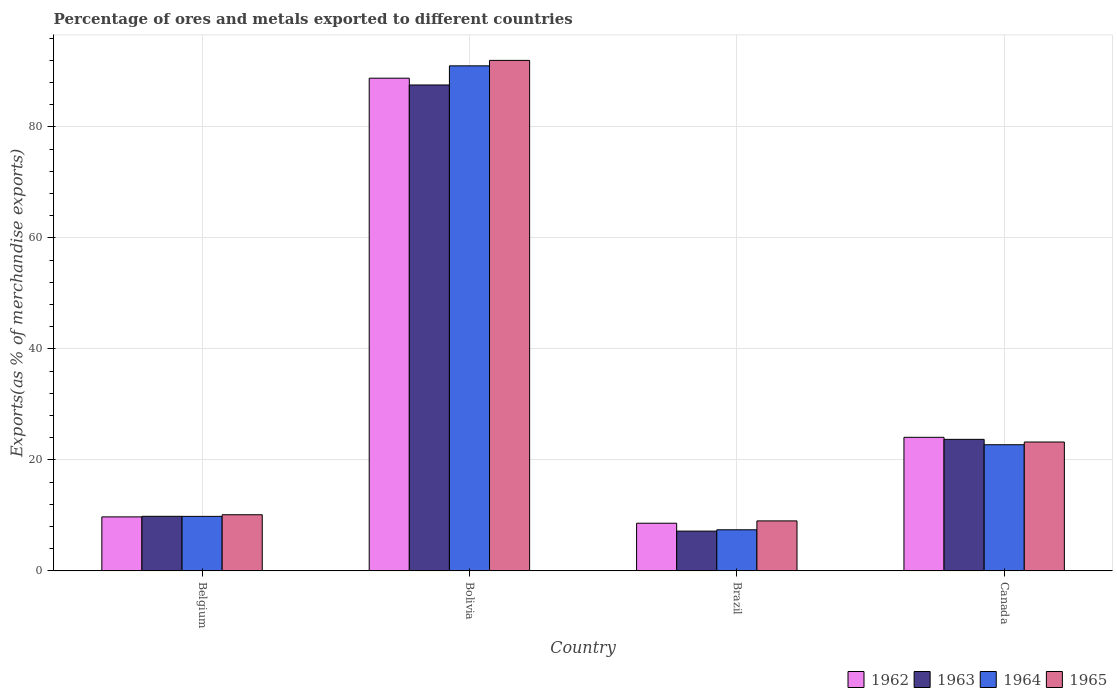How many different coloured bars are there?
Your answer should be very brief. 4. Are the number of bars on each tick of the X-axis equal?
Offer a very short reply. Yes. What is the label of the 1st group of bars from the left?
Provide a succinct answer. Belgium. In how many cases, is the number of bars for a given country not equal to the number of legend labels?
Make the answer very short. 0. What is the percentage of exports to different countries in 1964 in Brazil?
Offer a very short reply. 7.41. Across all countries, what is the maximum percentage of exports to different countries in 1965?
Offer a terse response. 92. Across all countries, what is the minimum percentage of exports to different countries in 1964?
Your answer should be compact. 7.41. What is the total percentage of exports to different countries in 1964 in the graph?
Offer a very short reply. 130.99. What is the difference between the percentage of exports to different countries in 1965 in Bolivia and that in Brazil?
Make the answer very short. 82.99. What is the difference between the percentage of exports to different countries in 1965 in Belgium and the percentage of exports to different countries in 1963 in Canada?
Provide a short and direct response. -13.59. What is the average percentage of exports to different countries in 1964 per country?
Give a very brief answer. 32.75. What is the difference between the percentage of exports to different countries of/in 1964 and percentage of exports to different countries of/in 1965 in Bolivia?
Your answer should be compact. -0.98. What is the ratio of the percentage of exports to different countries in 1963 in Bolivia to that in Canada?
Provide a succinct answer. 3.69. Is the percentage of exports to different countries in 1964 in Belgium less than that in Bolivia?
Your answer should be compact. Yes. What is the difference between the highest and the second highest percentage of exports to different countries in 1965?
Provide a succinct answer. -81.88. What is the difference between the highest and the lowest percentage of exports to different countries in 1965?
Give a very brief answer. 82.99. In how many countries, is the percentage of exports to different countries in 1964 greater than the average percentage of exports to different countries in 1964 taken over all countries?
Ensure brevity in your answer.  1. Is it the case that in every country, the sum of the percentage of exports to different countries in 1963 and percentage of exports to different countries in 1964 is greater than the sum of percentage of exports to different countries in 1962 and percentage of exports to different countries in 1965?
Your response must be concise. No. What does the 4th bar from the left in Belgium represents?
Offer a terse response. 1965. What does the 2nd bar from the right in Bolivia represents?
Give a very brief answer. 1964. Is it the case that in every country, the sum of the percentage of exports to different countries in 1965 and percentage of exports to different countries in 1963 is greater than the percentage of exports to different countries in 1962?
Ensure brevity in your answer.  Yes. How many countries are there in the graph?
Your answer should be very brief. 4. What is the difference between two consecutive major ticks on the Y-axis?
Provide a short and direct response. 20. Are the values on the major ticks of Y-axis written in scientific E-notation?
Offer a very short reply. No. Does the graph contain any zero values?
Give a very brief answer. No. How many legend labels are there?
Make the answer very short. 4. How are the legend labels stacked?
Your answer should be very brief. Horizontal. What is the title of the graph?
Keep it short and to the point. Percentage of ores and metals exported to different countries. What is the label or title of the X-axis?
Provide a succinct answer. Country. What is the label or title of the Y-axis?
Offer a terse response. Exports(as % of merchandise exports). What is the Exports(as % of merchandise exports) of 1962 in Belgium?
Keep it short and to the point. 9.73. What is the Exports(as % of merchandise exports) in 1963 in Belgium?
Keep it short and to the point. 9.84. What is the Exports(as % of merchandise exports) in 1964 in Belgium?
Provide a succinct answer. 9.83. What is the Exports(as % of merchandise exports) in 1965 in Belgium?
Your answer should be compact. 10.12. What is the Exports(as % of merchandise exports) in 1962 in Bolivia?
Your answer should be compact. 88.79. What is the Exports(as % of merchandise exports) in 1963 in Bolivia?
Your response must be concise. 87.57. What is the Exports(as % of merchandise exports) in 1964 in Bolivia?
Provide a succinct answer. 91.02. What is the Exports(as % of merchandise exports) in 1965 in Bolivia?
Offer a very short reply. 92. What is the Exports(as % of merchandise exports) of 1962 in Brazil?
Keep it short and to the point. 8.59. What is the Exports(as % of merchandise exports) in 1963 in Brazil?
Ensure brevity in your answer.  7.17. What is the Exports(as % of merchandise exports) in 1964 in Brazil?
Offer a terse response. 7.41. What is the Exports(as % of merchandise exports) in 1965 in Brazil?
Offer a terse response. 9.01. What is the Exports(as % of merchandise exports) in 1962 in Canada?
Offer a very short reply. 24.07. What is the Exports(as % of merchandise exports) in 1963 in Canada?
Your answer should be very brief. 23.71. What is the Exports(as % of merchandise exports) of 1964 in Canada?
Offer a very short reply. 22.74. What is the Exports(as % of merchandise exports) of 1965 in Canada?
Your answer should be compact. 23.23. Across all countries, what is the maximum Exports(as % of merchandise exports) of 1962?
Provide a short and direct response. 88.79. Across all countries, what is the maximum Exports(as % of merchandise exports) of 1963?
Keep it short and to the point. 87.57. Across all countries, what is the maximum Exports(as % of merchandise exports) in 1964?
Keep it short and to the point. 91.02. Across all countries, what is the maximum Exports(as % of merchandise exports) in 1965?
Your answer should be compact. 92. Across all countries, what is the minimum Exports(as % of merchandise exports) in 1962?
Your answer should be compact. 8.59. Across all countries, what is the minimum Exports(as % of merchandise exports) in 1963?
Your answer should be compact. 7.17. Across all countries, what is the minimum Exports(as % of merchandise exports) in 1964?
Provide a succinct answer. 7.41. Across all countries, what is the minimum Exports(as % of merchandise exports) of 1965?
Provide a succinct answer. 9.01. What is the total Exports(as % of merchandise exports) in 1962 in the graph?
Your answer should be compact. 131.19. What is the total Exports(as % of merchandise exports) in 1963 in the graph?
Give a very brief answer. 128.28. What is the total Exports(as % of merchandise exports) of 1964 in the graph?
Your answer should be compact. 130.99. What is the total Exports(as % of merchandise exports) in 1965 in the graph?
Your response must be concise. 134.36. What is the difference between the Exports(as % of merchandise exports) of 1962 in Belgium and that in Bolivia?
Ensure brevity in your answer.  -79.06. What is the difference between the Exports(as % of merchandise exports) in 1963 in Belgium and that in Bolivia?
Offer a terse response. -77.73. What is the difference between the Exports(as % of merchandise exports) of 1964 in Belgium and that in Bolivia?
Your answer should be compact. -81.19. What is the difference between the Exports(as % of merchandise exports) of 1965 in Belgium and that in Bolivia?
Offer a very short reply. -81.88. What is the difference between the Exports(as % of merchandise exports) in 1962 in Belgium and that in Brazil?
Offer a terse response. 1.14. What is the difference between the Exports(as % of merchandise exports) in 1963 in Belgium and that in Brazil?
Make the answer very short. 2.67. What is the difference between the Exports(as % of merchandise exports) of 1964 in Belgium and that in Brazil?
Offer a terse response. 2.42. What is the difference between the Exports(as % of merchandise exports) in 1965 in Belgium and that in Brazil?
Offer a terse response. 1.11. What is the difference between the Exports(as % of merchandise exports) in 1962 in Belgium and that in Canada?
Make the answer very short. -14.34. What is the difference between the Exports(as % of merchandise exports) in 1963 in Belgium and that in Canada?
Make the answer very short. -13.87. What is the difference between the Exports(as % of merchandise exports) of 1964 in Belgium and that in Canada?
Offer a terse response. -12.91. What is the difference between the Exports(as % of merchandise exports) of 1965 in Belgium and that in Canada?
Offer a very short reply. -13.11. What is the difference between the Exports(as % of merchandise exports) of 1962 in Bolivia and that in Brazil?
Provide a succinct answer. 80.2. What is the difference between the Exports(as % of merchandise exports) in 1963 in Bolivia and that in Brazil?
Keep it short and to the point. 80.4. What is the difference between the Exports(as % of merchandise exports) of 1964 in Bolivia and that in Brazil?
Provide a short and direct response. 83.61. What is the difference between the Exports(as % of merchandise exports) of 1965 in Bolivia and that in Brazil?
Provide a succinct answer. 82.99. What is the difference between the Exports(as % of merchandise exports) in 1962 in Bolivia and that in Canada?
Your answer should be very brief. 64.72. What is the difference between the Exports(as % of merchandise exports) in 1963 in Bolivia and that in Canada?
Your response must be concise. 63.86. What is the difference between the Exports(as % of merchandise exports) of 1964 in Bolivia and that in Canada?
Offer a terse response. 68.28. What is the difference between the Exports(as % of merchandise exports) in 1965 in Bolivia and that in Canada?
Your answer should be very brief. 68.77. What is the difference between the Exports(as % of merchandise exports) of 1962 in Brazil and that in Canada?
Offer a terse response. -15.48. What is the difference between the Exports(as % of merchandise exports) of 1963 in Brazil and that in Canada?
Provide a short and direct response. -16.54. What is the difference between the Exports(as % of merchandise exports) in 1964 in Brazil and that in Canada?
Offer a terse response. -15.33. What is the difference between the Exports(as % of merchandise exports) in 1965 in Brazil and that in Canada?
Offer a very short reply. -14.22. What is the difference between the Exports(as % of merchandise exports) of 1962 in Belgium and the Exports(as % of merchandise exports) of 1963 in Bolivia?
Provide a succinct answer. -77.84. What is the difference between the Exports(as % of merchandise exports) in 1962 in Belgium and the Exports(as % of merchandise exports) in 1964 in Bolivia?
Offer a terse response. -81.28. What is the difference between the Exports(as % of merchandise exports) of 1962 in Belgium and the Exports(as % of merchandise exports) of 1965 in Bolivia?
Offer a very short reply. -82.27. What is the difference between the Exports(as % of merchandise exports) of 1963 in Belgium and the Exports(as % of merchandise exports) of 1964 in Bolivia?
Give a very brief answer. -81.18. What is the difference between the Exports(as % of merchandise exports) of 1963 in Belgium and the Exports(as % of merchandise exports) of 1965 in Bolivia?
Provide a succinct answer. -82.16. What is the difference between the Exports(as % of merchandise exports) of 1964 in Belgium and the Exports(as % of merchandise exports) of 1965 in Bolivia?
Your response must be concise. -82.17. What is the difference between the Exports(as % of merchandise exports) of 1962 in Belgium and the Exports(as % of merchandise exports) of 1963 in Brazil?
Give a very brief answer. 2.56. What is the difference between the Exports(as % of merchandise exports) of 1962 in Belgium and the Exports(as % of merchandise exports) of 1964 in Brazil?
Your answer should be compact. 2.33. What is the difference between the Exports(as % of merchandise exports) in 1962 in Belgium and the Exports(as % of merchandise exports) in 1965 in Brazil?
Make the answer very short. 0.72. What is the difference between the Exports(as % of merchandise exports) of 1963 in Belgium and the Exports(as % of merchandise exports) of 1964 in Brazil?
Your answer should be compact. 2.43. What is the difference between the Exports(as % of merchandise exports) in 1963 in Belgium and the Exports(as % of merchandise exports) in 1965 in Brazil?
Offer a very short reply. 0.83. What is the difference between the Exports(as % of merchandise exports) in 1964 in Belgium and the Exports(as % of merchandise exports) in 1965 in Brazil?
Your answer should be very brief. 0.82. What is the difference between the Exports(as % of merchandise exports) in 1962 in Belgium and the Exports(as % of merchandise exports) in 1963 in Canada?
Provide a short and direct response. -13.97. What is the difference between the Exports(as % of merchandise exports) in 1962 in Belgium and the Exports(as % of merchandise exports) in 1964 in Canada?
Your response must be concise. -13. What is the difference between the Exports(as % of merchandise exports) of 1962 in Belgium and the Exports(as % of merchandise exports) of 1965 in Canada?
Make the answer very short. -13.49. What is the difference between the Exports(as % of merchandise exports) in 1963 in Belgium and the Exports(as % of merchandise exports) in 1964 in Canada?
Your answer should be compact. -12.9. What is the difference between the Exports(as % of merchandise exports) in 1963 in Belgium and the Exports(as % of merchandise exports) in 1965 in Canada?
Keep it short and to the point. -13.39. What is the difference between the Exports(as % of merchandise exports) of 1964 in Belgium and the Exports(as % of merchandise exports) of 1965 in Canada?
Your answer should be compact. -13.4. What is the difference between the Exports(as % of merchandise exports) in 1962 in Bolivia and the Exports(as % of merchandise exports) in 1963 in Brazil?
Your response must be concise. 81.62. What is the difference between the Exports(as % of merchandise exports) of 1962 in Bolivia and the Exports(as % of merchandise exports) of 1964 in Brazil?
Keep it short and to the point. 81.39. What is the difference between the Exports(as % of merchandise exports) in 1962 in Bolivia and the Exports(as % of merchandise exports) in 1965 in Brazil?
Provide a succinct answer. 79.78. What is the difference between the Exports(as % of merchandise exports) in 1963 in Bolivia and the Exports(as % of merchandise exports) in 1964 in Brazil?
Provide a succinct answer. 80.16. What is the difference between the Exports(as % of merchandise exports) of 1963 in Bolivia and the Exports(as % of merchandise exports) of 1965 in Brazil?
Offer a terse response. 78.56. What is the difference between the Exports(as % of merchandise exports) in 1964 in Bolivia and the Exports(as % of merchandise exports) in 1965 in Brazil?
Make the answer very short. 82.01. What is the difference between the Exports(as % of merchandise exports) of 1962 in Bolivia and the Exports(as % of merchandise exports) of 1963 in Canada?
Keep it short and to the point. 65.09. What is the difference between the Exports(as % of merchandise exports) of 1962 in Bolivia and the Exports(as % of merchandise exports) of 1964 in Canada?
Provide a short and direct response. 66.06. What is the difference between the Exports(as % of merchandise exports) in 1962 in Bolivia and the Exports(as % of merchandise exports) in 1965 in Canada?
Offer a terse response. 65.57. What is the difference between the Exports(as % of merchandise exports) in 1963 in Bolivia and the Exports(as % of merchandise exports) in 1964 in Canada?
Offer a very short reply. 64.83. What is the difference between the Exports(as % of merchandise exports) in 1963 in Bolivia and the Exports(as % of merchandise exports) in 1965 in Canada?
Give a very brief answer. 64.34. What is the difference between the Exports(as % of merchandise exports) in 1964 in Bolivia and the Exports(as % of merchandise exports) in 1965 in Canada?
Give a very brief answer. 67.79. What is the difference between the Exports(as % of merchandise exports) of 1962 in Brazil and the Exports(as % of merchandise exports) of 1963 in Canada?
Give a very brief answer. -15.11. What is the difference between the Exports(as % of merchandise exports) of 1962 in Brazil and the Exports(as % of merchandise exports) of 1964 in Canada?
Your answer should be very brief. -14.15. What is the difference between the Exports(as % of merchandise exports) in 1962 in Brazil and the Exports(as % of merchandise exports) in 1965 in Canada?
Provide a short and direct response. -14.64. What is the difference between the Exports(as % of merchandise exports) of 1963 in Brazil and the Exports(as % of merchandise exports) of 1964 in Canada?
Keep it short and to the point. -15.57. What is the difference between the Exports(as % of merchandise exports) of 1963 in Brazil and the Exports(as % of merchandise exports) of 1965 in Canada?
Provide a short and direct response. -16.06. What is the difference between the Exports(as % of merchandise exports) of 1964 in Brazil and the Exports(as % of merchandise exports) of 1965 in Canada?
Offer a very short reply. -15.82. What is the average Exports(as % of merchandise exports) of 1962 per country?
Provide a short and direct response. 32.8. What is the average Exports(as % of merchandise exports) of 1963 per country?
Offer a terse response. 32.07. What is the average Exports(as % of merchandise exports) of 1964 per country?
Your answer should be compact. 32.75. What is the average Exports(as % of merchandise exports) in 1965 per country?
Give a very brief answer. 33.59. What is the difference between the Exports(as % of merchandise exports) of 1962 and Exports(as % of merchandise exports) of 1963 in Belgium?
Offer a terse response. -0.1. What is the difference between the Exports(as % of merchandise exports) of 1962 and Exports(as % of merchandise exports) of 1964 in Belgium?
Keep it short and to the point. -0.09. What is the difference between the Exports(as % of merchandise exports) of 1962 and Exports(as % of merchandise exports) of 1965 in Belgium?
Offer a very short reply. -0.39. What is the difference between the Exports(as % of merchandise exports) of 1963 and Exports(as % of merchandise exports) of 1964 in Belgium?
Provide a short and direct response. 0.01. What is the difference between the Exports(as % of merchandise exports) in 1963 and Exports(as % of merchandise exports) in 1965 in Belgium?
Provide a short and direct response. -0.28. What is the difference between the Exports(as % of merchandise exports) in 1964 and Exports(as % of merchandise exports) in 1965 in Belgium?
Ensure brevity in your answer.  -0.29. What is the difference between the Exports(as % of merchandise exports) of 1962 and Exports(as % of merchandise exports) of 1963 in Bolivia?
Keep it short and to the point. 1.22. What is the difference between the Exports(as % of merchandise exports) of 1962 and Exports(as % of merchandise exports) of 1964 in Bolivia?
Provide a succinct answer. -2.22. What is the difference between the Exports(as % of merchandise exports) in 1962 and Exports(as % of merchandise exports) in 1965 in Bolivia?
Keep it short and to the point. -3.21. What is the difference between the Exports(as % of merchandise exports) of 1963 and Exports(as % of merchandise exports) of 1964 in Bolivia?
Provide a succinct answer. -3.45. What is the difference between the Exports(as % of merchandise exports) in 1963 and Exports(as % of merchandise exports) in 1965 in Bolivia?
Give a very brief answer. -4.43. What is the difference between the Exports(as % of merchandise exports) in 1964 and Exports(as % of merchandise exports) in 1965 in Bolivia?
Ensure brevity in your answer.  -0.98. What is the difference between the Exports(as % of merchandise exports) in 1962 and Exports(as % of merchandise exports) in 1963 in Brazil?
Provide a succinct answer. 1.42. What is the difference between the Exports(as % of merchandise exports) of 1962 and Exports(as % of merchandise exports) of 1964 in Brazil?
Ensure brevity in your answer.  1.18. What is the difference between the Exports(as % of merchandise exports) of 1962 and Exports(as % of merchandise exports) of 1965 in Brazil?
Keep it short and to the point. -0.42. What is the difference between the Exports(as % of merchandise exports) in 1963 and Exports(as % of merchandise exports) in 1964 in Brazil?
Your answer should be compact. -0.24. What is the difference between the Exports(as % of merchandise exports) of 1963 and Exports(as % of merchandise exports) of 1965 in Brazil?
Offer a very short reply. -1.84. What is the difference between the Exports(as % of merchandise exports) in 1964 and Exports(as % of merchandise exports) in 1965 in Brazil?
Keep it short and to the point. -1.6. What is the difference between the Exports(as % of merchandise exports) of 1962 and Exports(as % of merchandise exports) of 1963 in Canada?
Your response must be concise. 0.37. What is the difference between the Exports(as % of merchandise exports) of 1962 and Exports(as % of merchandise exports) of 1964 in Canada?
Provide a succinct answer. 1.33. What is the difference between the Exports(as % of merchandise exports) of 1962 and Exports(as % of merchandise exports) of 1965 in Canada?
Provide a succinct answer. 0.84. What is the difference between the Exports(as % of merchandise exports) in 1963 and Exports(as % of merchandise exports) in 1964 in Canada?
Your response must be concise. 0.97. What is the difference between the Exports(as % of merchandise exports) in 1963 and Exports(as % of merchandise exports) in 1965 in Canada?
Make the answer very short. 0.48. What is the difference between the Exports(as % of merchandise exports) in 1964 and Exports(as % of merchandise exports) in 1965 in Canada?
Your answer should be compact. -0.49. What is the ratio of the Exports(as % of merchandise exports) of 1962 in Belgium to that in Bolivia?
Give a very brief answer. 0.11. What is the ratio of the Exports(as % of merchandise exports) of 1963 in Belgium to that in Bolivia?
Offer a terse response. 0.11. What is the ratio of the Exports(as % of merchandise exports) in 1964 in Belgium to that in Bolivia?
Ensure brevity in your answer.  0.11. What is the ratio of the Exports(as % of merchandise exports) of 1965 in Belgium to that in Bolivia?
Keep it short and to the point. 0.11. What is the ratio of the Exports(as % of merchandise exports) in 1962 in Belgium to that in Brazil?
Keep it short and to the point. 1.13. What is the ratio of the Exports(as % of merchandise exports) in 1963 in Belgium to that in Brazil?
Offer a terse response. 1.37. What is the ratio of the Exports(as % of merchandise exports) in 1964 in Belgium to that in Brazil?
Make the answer very short. 1.33. What is the ratio of the Exports(as % of merchandise exports) in 1965 in Belgium to that in Brazil?
Ensure brevity in your answer.  1.12. What is the ratio of the Exports(as % of merchandise exports) of 1962 in Belgium to that in Canada?
Offer a very short reply. 0.4. What is the ratio of the Exports(as % of merchandise exports) of 1963 in Belgium to that in Canada?
Make the answer very short. 0.41. What is the ratio of the Exports(as % of merchandise exports) of 1964 in Belgium to that in Canada?
Provide a short and direct response. 0.43. What is the ratio of the Exports(as % of merchandise exports) in 1965 in Belgium to that in Canada?
Offer a very short reply. 0.44. What is the ratio of the Exports(as % of merchandise exports) in 1962 in Bolivia to that in Brazil?
Offer a very short reply. 10.33. What is the ratio of the Exports(as % of merchandise exports) in 1963 in Bolivia to that in Brazil?
Provide a short and direct response. 12.21. What is the ratio of the Exports(as % of merchandise exports) in 1964 in Bolivia to that in Brazil?
Provide a succinct answer. 12.29. What is the ratio of the Exports(as % of merchandise exports) of 1965 in Bolivia to that in Brazil?
Offer a very short reply. 10.21. What is the ratio of the Exports(as % of merchandise exports) of 1962 in Bolivia to that in Canada?
Your response must be concise. 3.69. What is the ratio of the Exports(as % of merchandise exports) of 1963 in Bolivia to that in Canada?
Ensure brevity in your answer.  3.69. What is the ratio of the Exports(as % of merchandise exports) of 1964 in Bolivia to that in Canada?
Offer a very short reply. 4. What is the ratio of the Exports(as % of merchandise exports) of 1965 in Bolivia to that in Canada?
Offer a very short reply. 3.96. What is the ratio of the Exports(as % of merchandise exports) in 1962 in Brazil to that in Canada?
Make the answer very short. 0.36. What is the ratio of the Exports(as % of merchandise exports) of 1963 in Brazil to that in Canada?
Make the answer very short. 0.3. What is the ratio of the Exports(as % of merchandise exports) in 1964 in Brazil to that in Canada?
Offer a terse response. 0.33. What is the ratio of the Exports(as % of merchandise exports) of 1965 in Brazil to that in Canada?
Provide a succinct answer. 0.39. What is the difference between the highest and the second highest Exports(as % of merchandise exports) in 1962?
Keep it short and to the point. 64.72. What is the difference between the highest and the second highest Exports(as % of merchandise exports) of 1963?
Provide a succinct answer. 63.86. What is the difference between the highest and the second highest Exports(as % of merchandise exports) in 1964?
Provide a succinct answer. 68.28. What is the difference between the highest and the second highest Exports(as % of merchandise exports) in 1965?
Make the answer very short. 68.77. What is the difference between the highest and the lowest Exports(as % of merchandise exports) of 1962?
Ensure brevity in your answer.  80.2. What is the difference between the highest and the lowest Exports(as % of merchandise exports) of 1963?
Your response must be concise. 80.4. What is the difference between the highest and the lowest Exports(as % of merchandise exports) of 1964?
Offer a terse response. 83.61. What is the difference between the highest and the lowest Exports(as % of merchandise exports) in 1965?
Your answer should be very brief. 82.99. 